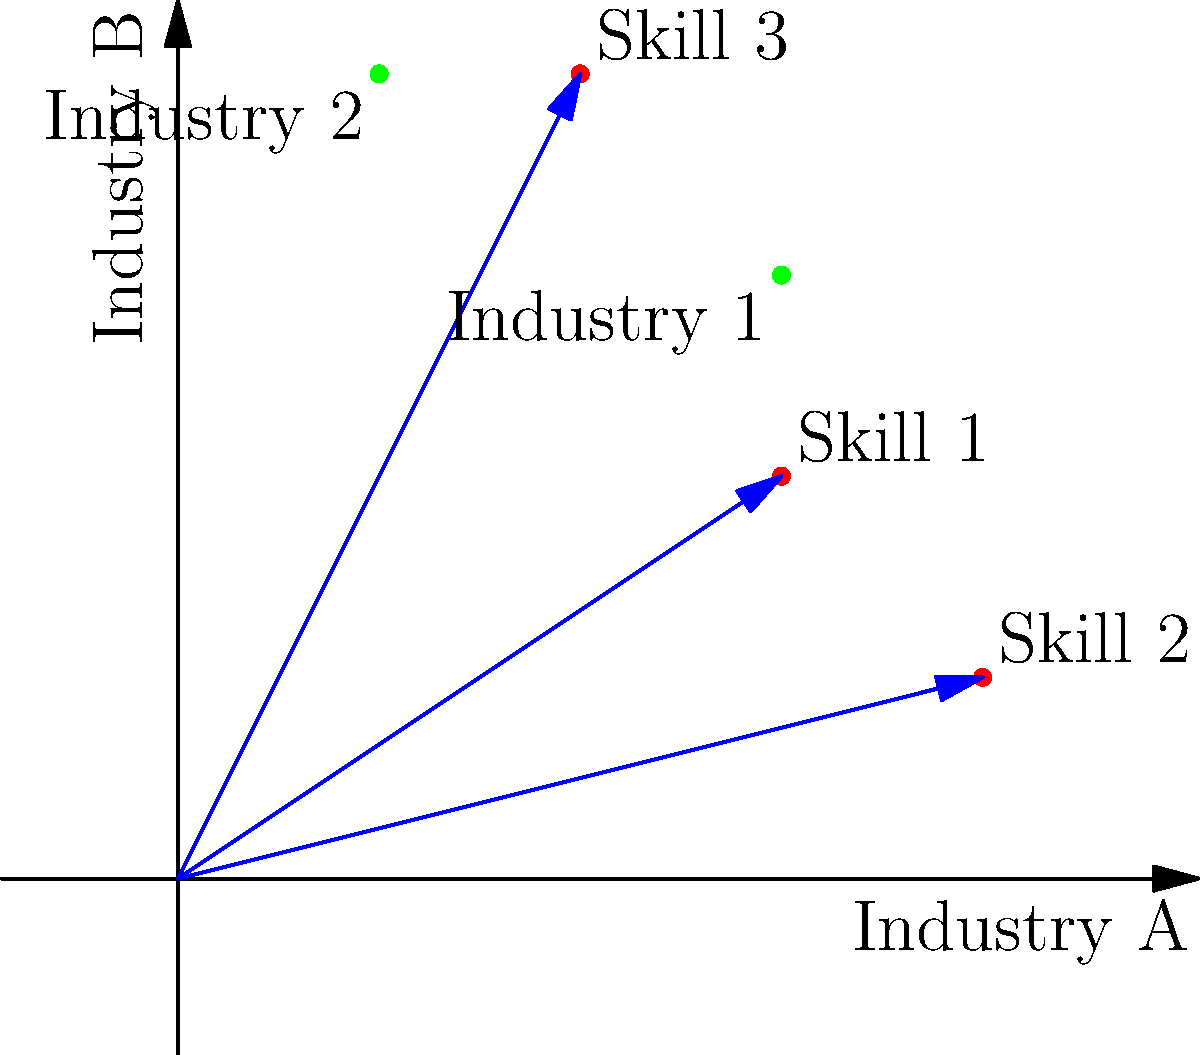As a CEO transitioning to a new industry, you've identified three transferable skills represented as vectors in a 2D space where the x-axis represents alignment with Industry A and the y-axis represents alignment with Industry B. Skill 1 is represented by vector $\vec{v_1} = (3,2)$, Skill 2 by $\vec{v_2} = (4,1)$, and Skill 3 by $\vec{v_3} = (2,4)$. Two potential new industries are also represented as points: Industry 1 at (3,3) and Industry 2 at (1,4). Which industry aligns best with your combined skillset, and what is the magnitude of the difference vector between your combined skills and the chosen industry? To solve this problem, we'll follow these steps:

1) First, we need to combine the skill vectors to get a representation of the overall skillset:
   $\vec{v_{total}} = \vec{v_1} + \vec{v_2} + \vec{v_3} = (3,2) + (4,1) + (2,4) = (9,7)$

2) Now, we need to calculate the distance between this total skill vector and each industry point. We can do this using the distance formula:
   $d = \sqrt{(x_2-x_1)^2 + (y_2-y_1)^2}$

   For Industry 1: $d_1 = \sqrt{(3-9)^2 + (3-7)^2} = \sqrt{36 + 16} = \sqrt{52} \approx 7.21$
   For Industry 2: $d_2 = \sqrt{(1-9)^2 + (4-7)^2} = \sqrt{64 + 9} = \sqrt{73} \approx 8.54$

3) The industry with the smaller distance aligns best with the combined skillset. In this case, it's Industry 1.

4) The difference vector between the combined skills and Industry 1 is:
   $\vec{diff} = (3,3) - (9,7) = (-6,-4)$

5) The magnitude of this difference vector is:
   $|\vec{diff}| = \sqrt{(-6)^2 + (-4)^2} = \sqrt{36 + 16} = \sqrt{52} \approx 7.21$
Answer: Industry 1; 7.21 